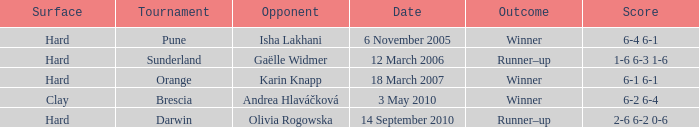Could you parse the entire table as a dict? {'header': ['Surface', 'Tournament', 'Opponent', 'Date', 'Outcome', 'Score'], 'rows': [['Hard', 'Pune', 'Isha Lakhani', '6 November 2005', 'Winner', '6-4 6-1'], ['Hard', 'Sunderland', 'Gaëlle Widmer', '12 March 2006', 'Runner–up', '1-6 6-3 1-6'], ['Hard', 'Orange', 'Karin Knapp', '18 March 2007', 'Winner', '6-1 6-1'], ['Clay', 'Brescia', 'Andrea Hlaváčková', '3 May 2010', 'Winner', '6-2 6-4'], ['Hard', 'Darwin', 'Olivia Rogowska', '14 September 2010', 'Runner–up', '2-6 6-2 0-6']]} When was the tournament at Orange? 18 March 2007. 